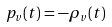Convert formula to latex. <formula><loc_0><loc_0><loc_500><loc_500>p _ { v } ( t ) = - \rho _ { v } ( t )</formula> 